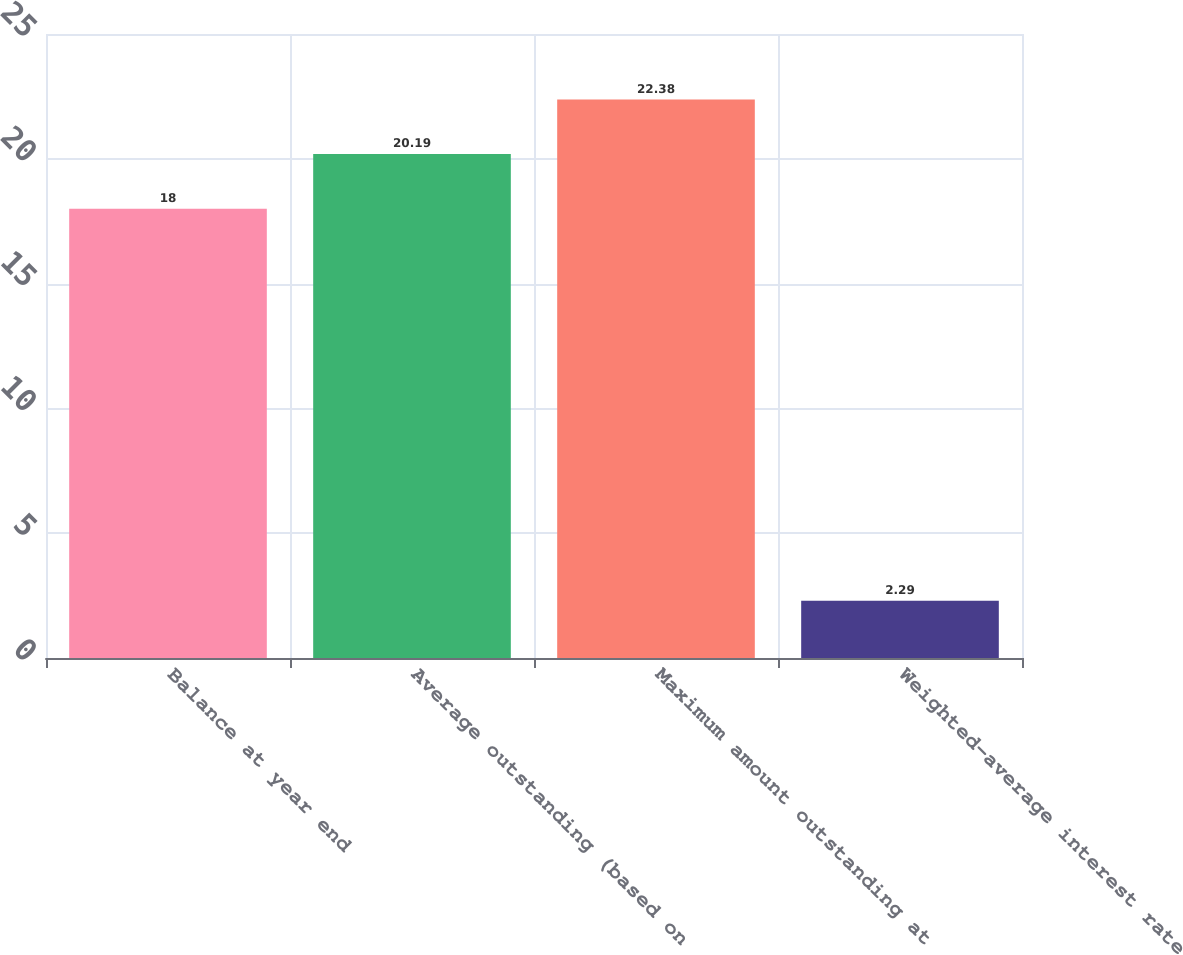Convert chart to OTSL. <chart><loc_0><loc_0><loc_500><loc_500><bar_chart><fcel>Balance at year end<fcel>Average outstanding (based on<fcel>Maximum amount outstanding at<fcel>Weighted-average interest rate<nl><fcel>18<fcel>20.19<fcel>22.38<fcel>2.29<nl></chart> 